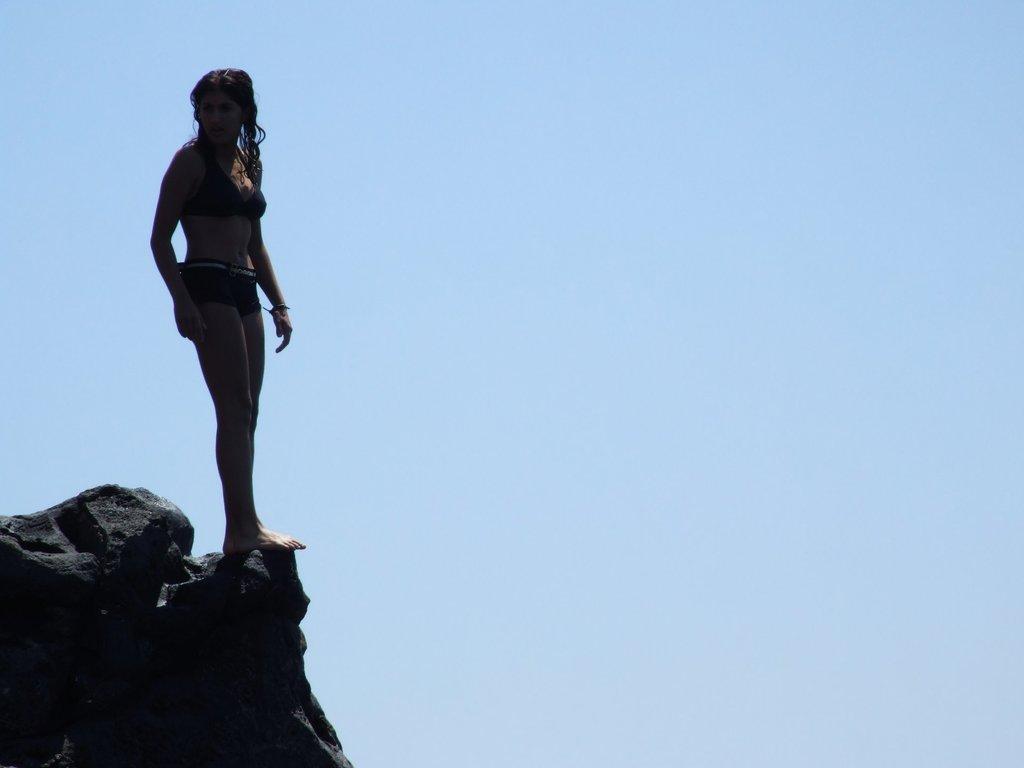In one or two sentences, can you explain what this image depicts? In this image we can see a lady standing on a rock. In the back there is sky. 